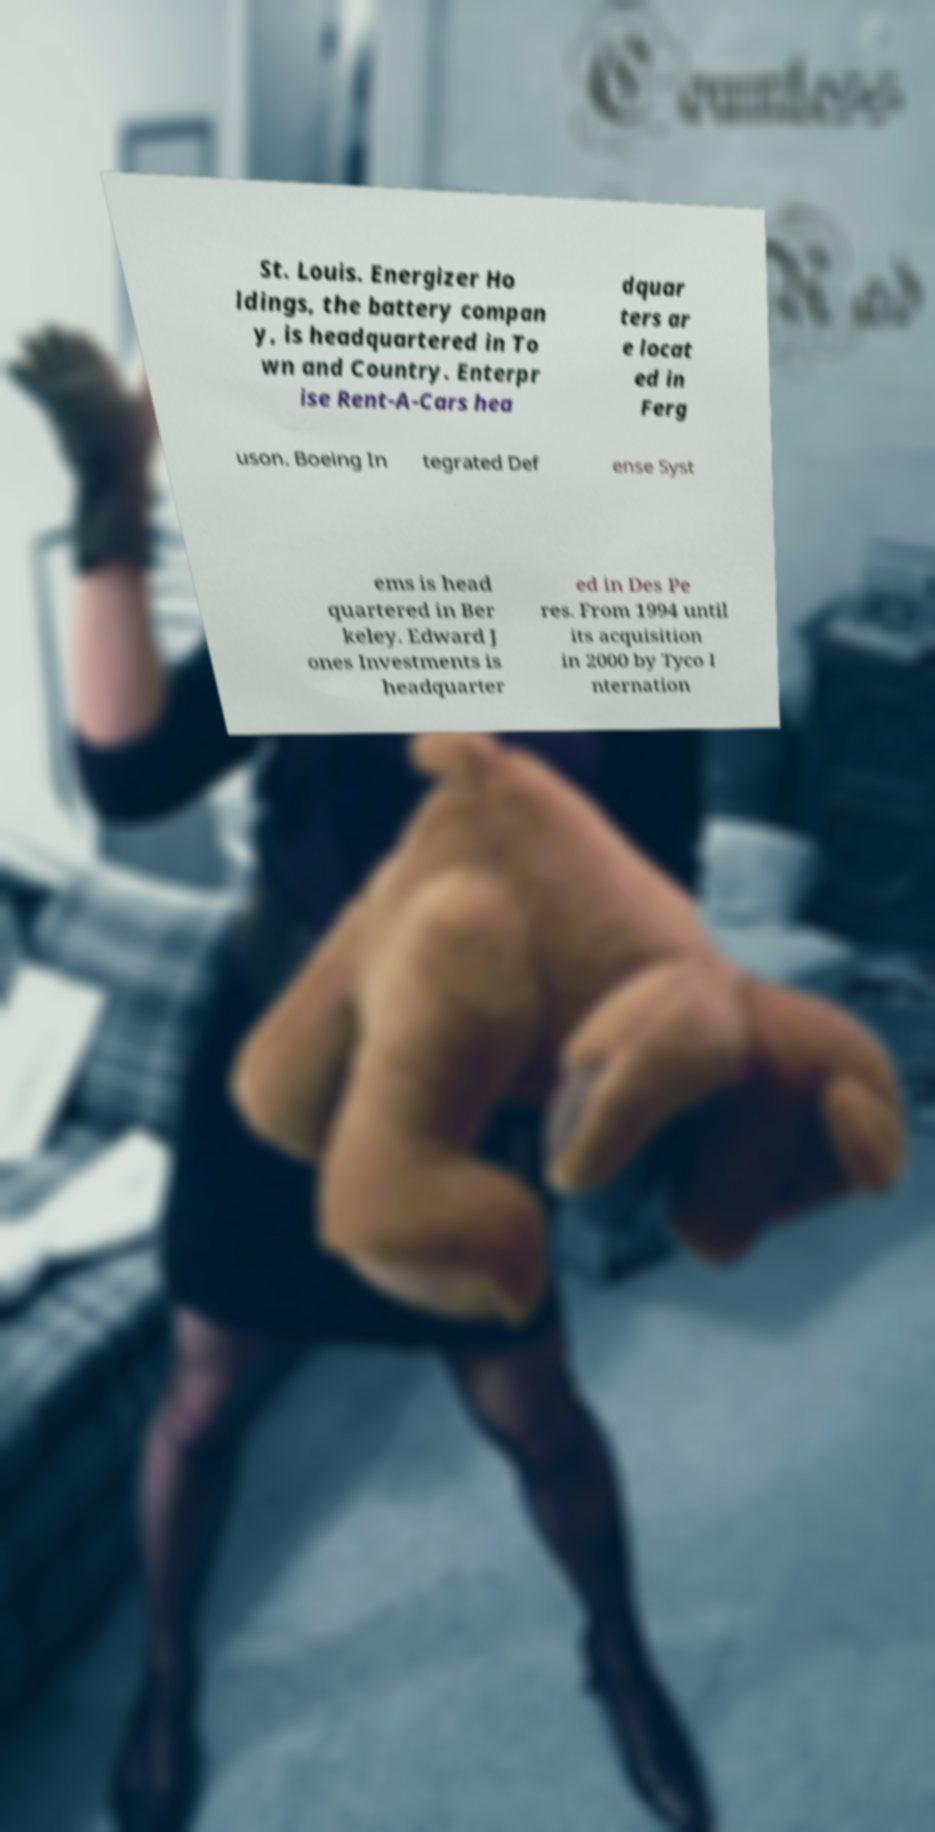Could you extract and type out the text from this image? St. Louis. Energizer Ho ldings, the battery compan y, is headquartered in To wn and Country. Enterpr ise Rent-A-Cars hea dquar ters ar e locat ed in Ferg uson. Boeing In tegrated Def ense Syst ems is head quartered in Ber keley. Edward J ones Investments is headquarter ed in Des Pe res. From 1994 until its acquisition in 2000 by Tyco I nternation 